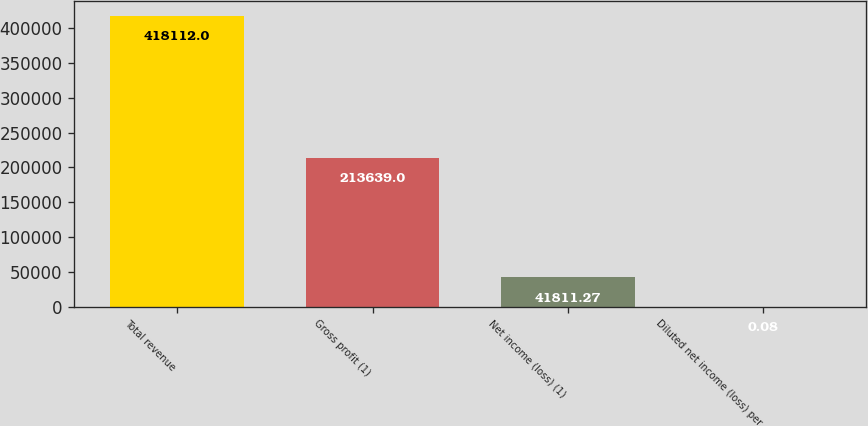Convert chart to OTSL. <chart><loc_0><loc_0><loc_500><loc_500><bar_chart><fcel>Total revenue<fcel>Gross profit (1)<fcel>Net income (loss) (1)<fcel>Diluted net income (loss) per<nl><fcel>418112<fcel>213639<fcel>41811.3<fcel>0.08<nl></chart> 